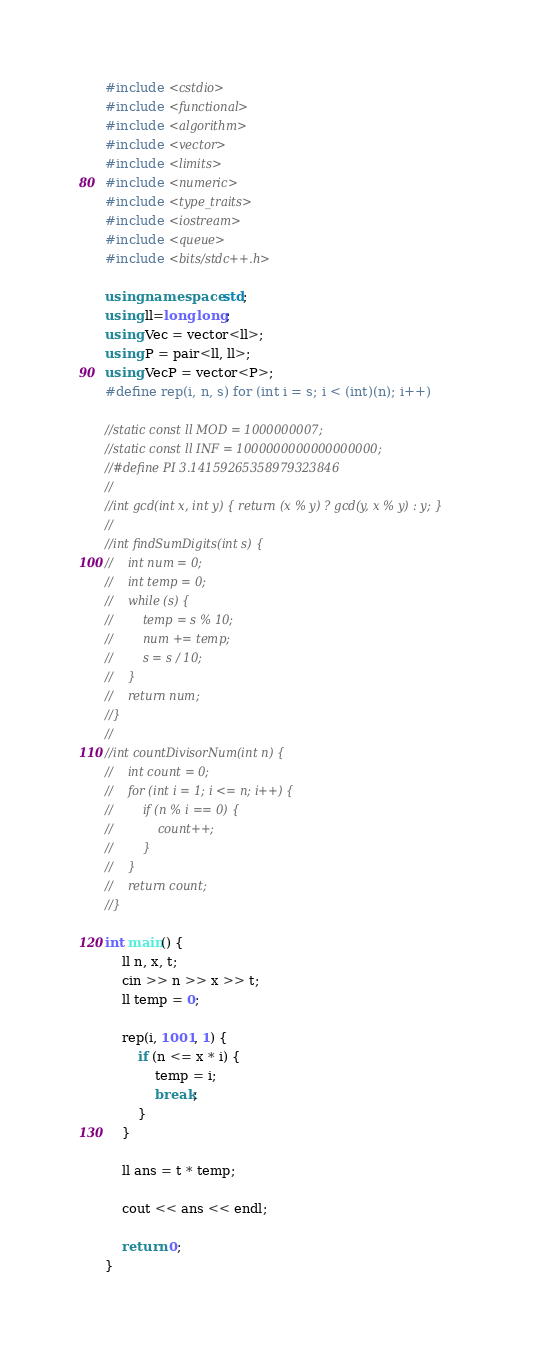<code> <loc_0><loc_0><loc_500><loc_500><_C++_>#include <cstdio>
#include <functional>
#include <algorithm>
#include <vector>
#include <limits>
#include <numeric>
#include <type_traits>
#include <iostream>
#include <queue>
#include <bits/stdc++.h>

using namespace std;
using ll=long long;
using Vec = vector<ll>;
using P = pair<ll, ll>;
using VecP = vector<P>;
#define rep(i, n, s) for (int i = s; i < (int)(n); i++)

//static const ll MOD = 1000000007;
//static const ll INF = 1000000000000000000;
//#define PI 3.14159265358979323846
//
//int gcd(int x, int y) { return (x % y) ? gcd(y, x % y) : y; }
//
//int findSumDigits(int s) {
//    int num = 0;
//    int temp = 0;
//    while (s) {
//        temp = s % 10;
//        num += temp;
//        s = s / 10;
//    }
//    return num;
//}
//
//int countDivisorNum(int n) {
//    int count = 0;
//    for (int i = 1; i <= n; i++) {
//        if (n % i == 0) {
//            count++;
//        }
//    }
//    return count;
//}

int main() {
    ll n, x, t;
    cin >> n >> x >> t;
    ll temp = 0;

    rep(i, 1001, 1) {
        if (n <= x * i) {
            temp = i;
            break;
        }
    }

    ll ans = t * temp;

    cout << ans << endl;

    return 0;
}</code> 